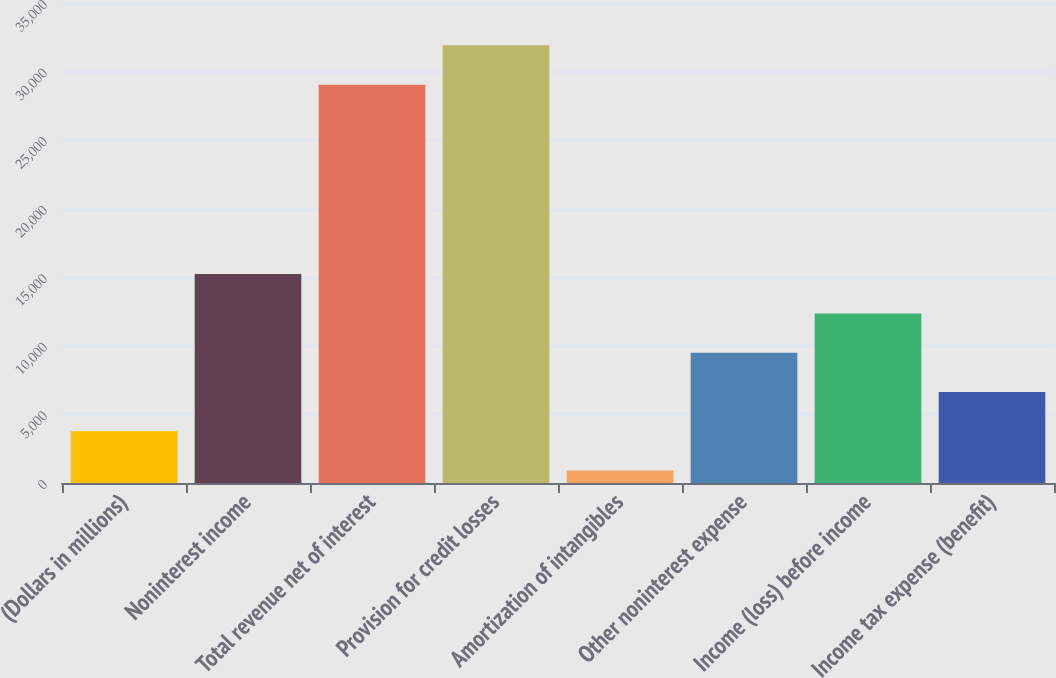Convert chart. <chart><loc_0><loc_0><loc_500><loc_500><bar_chart><fcel>(Dollars in millions)<fcel>Noninterest income<fcel>Total revenue net of interest<fcel>Provision for credit losses<fcel>Amortization of intangibles<fcel>Other noninterest expense<fcel>Income (loss) before income<fcel>Income tax expense (benefit)<nl><fcel>3775.2<fcel>15232<fcel>29046<fcel>31910.2<fcel>911<fcel>9503.6<fcel>12367.8<fcel>6639.4<nl></chart> 